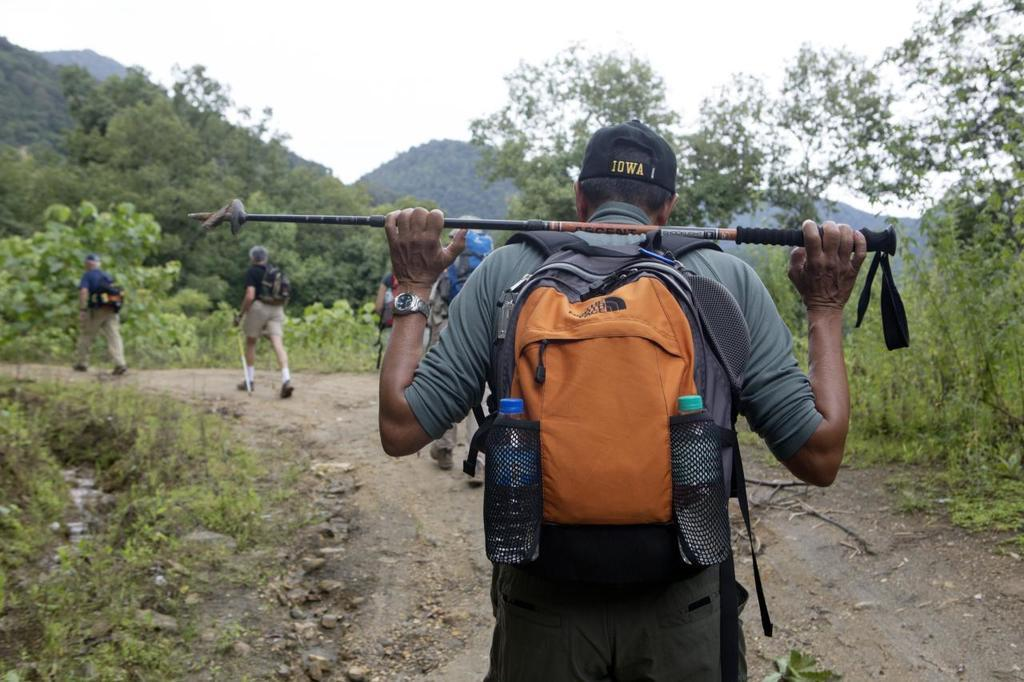<image>
Render a clear and concise summary of the photo. a hat on a person that says Iowa on it 